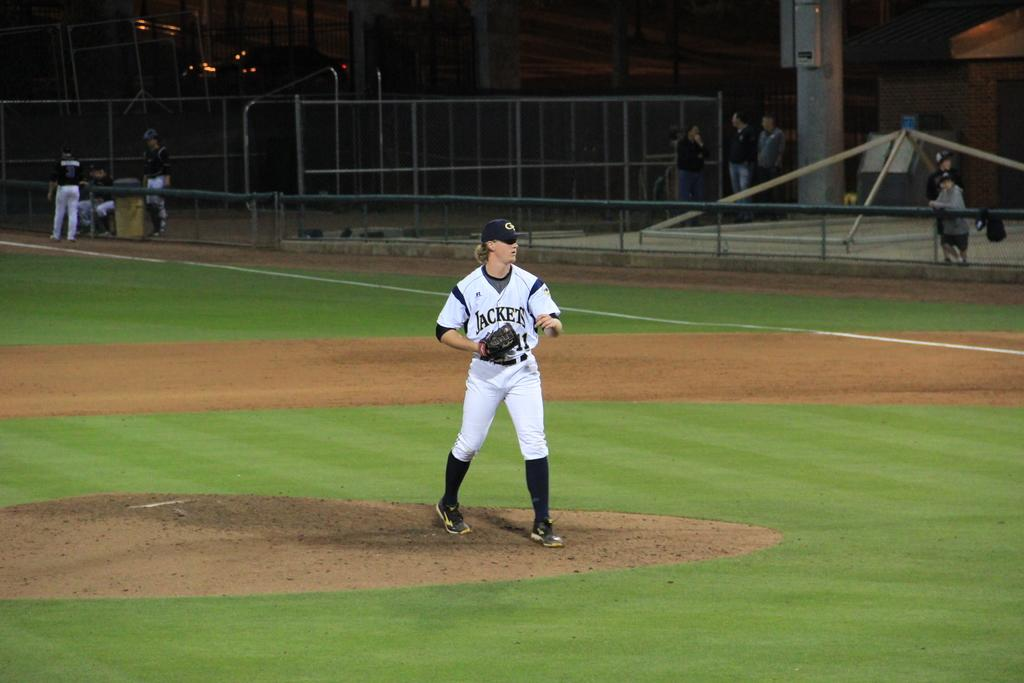<image>
Relay a brief, clear account of the picture shown. A Jacket's baseball player waits for the ball to be thrown back to him. 